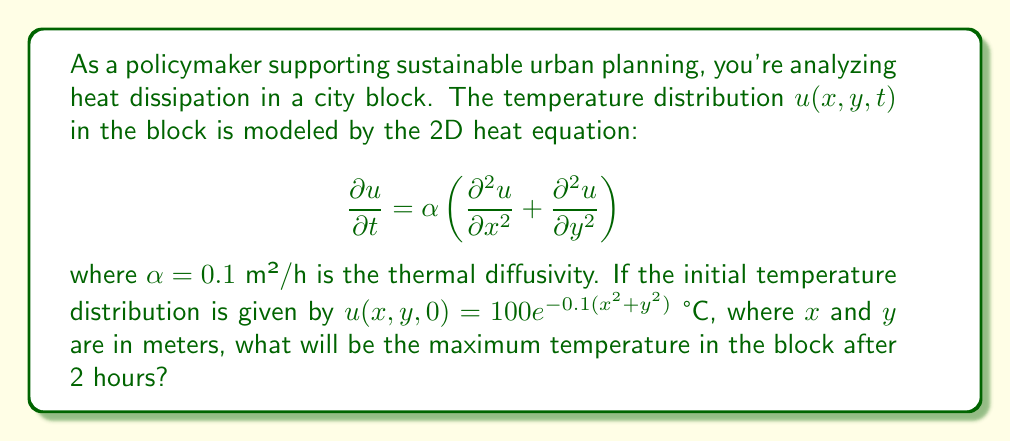Give your solution to this math problem. To solve this problem, we'll follow these steps:

1) The general solution to the 2D heat equation is:

   $$u(x,y,t) = \frac{1}{4\pi\alpha t}\int\int u(x',y',0)e^{-\frac{(x-x')^2+(y-y')^2}{4\alpha t}}dx'dy'$$

2) In our case, $u(x',y',0) = 100e^{-0.1(x'^2+y'^2)}$

3) Substituting this into the general solution:

   $$u(x,y,t) = \frac{100}{4\pi\alpha t}\int\int e^{-0.1(x'^2+y'^2)}e^{-\frac{(x-x')^2+(y-y')^2}{4\alpha t}}dx'dy'$$

4) This integral can be solved analytically, resulting in:

   $$u(x,y,t) = \frac{100}{1+0.4\alpha t}e^{-\frac{0.1(x^2+y^2)}{1+0.4\alpha t}}$$

5) The maximum temperature will occur at the center (x=0, y=0) at any given time. So:

   $$u_{max}(t) = \frac{100}{1+0.4\alpha t}$$

6) Substituting the given values ($\alpha = 0.1$ m²/h, t = 2 h):

   $$u_{max}(2) = \frac{100}{1+0.4(0.1)(2)} = \frac{100}{1.08} \approx 92.59 \text{ °C}$$

Therefore, the maximum temperature in the block after 2 hours will be approximately 92.59 °C.
Answer: 92.59 °C 